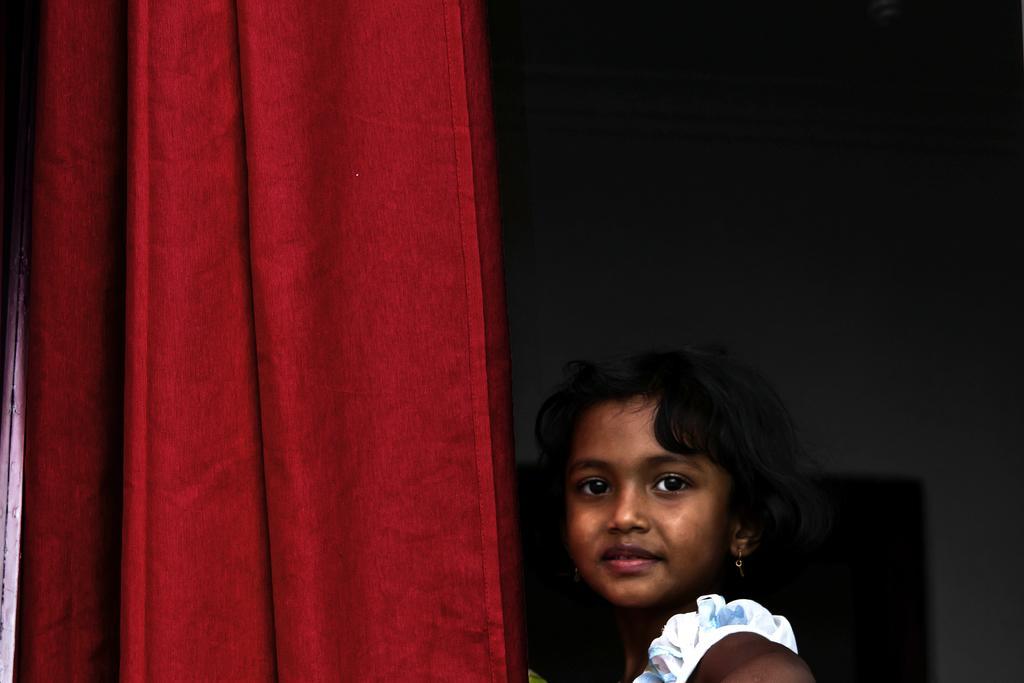Can you describe this image briefly? In the center of the image a girl is there. On the left side of the image curtain is there. In the background of the image wall is there. 